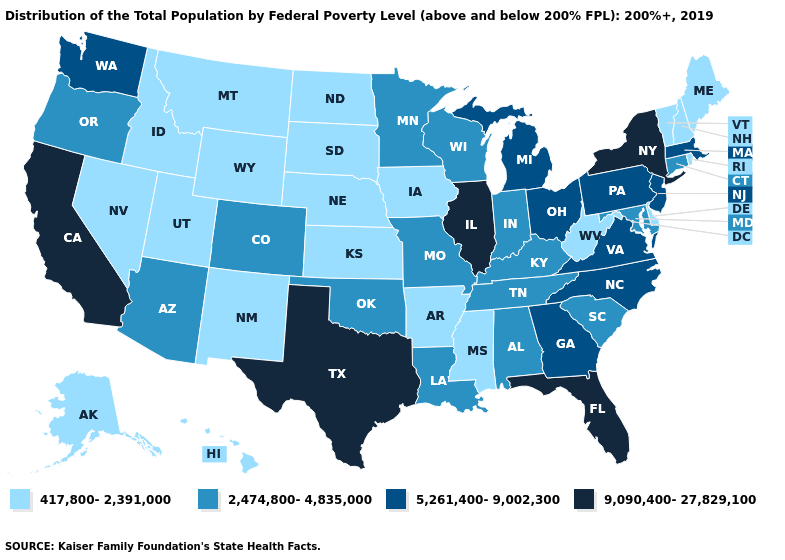Does North Dakota have a lower value than Maryland?
Answer briefly. Yes. Does Wyoming have the same value as Maryland?
Answer briefly. No. How many symbols are there in the legend?
Answer briefly. 4. Does Washington have a higher value than Florida?
Be succinct. No. Name the states that have a value in the range 417,800-2,391,000?
Write a very short answer. Alaska, Arkansas, Delaware, Hawaii, Idaho, Iowa, Kansas, Maine, Mississippi, Montana, Nebraska, Nevada, New Hampshire, New Mexico, North Dakota, Rhode Island, South Dakota, Utah, Vermont, West Virginia, Wyoming. How many symbols are there in the legend?
Short answer required. 4. Does North Carolina have a lower value than Illinois?
Concise answer only. Yes. Among the states that border Virginia , does North Carolina have the highest value?
Give a very brief answer. Yes. What is the highest value in states that border Virginia?
Answer briefly. 5,261,400-9,002,300. Name the states that have a value in the range 5,261,400-9,002,300?
Give a very brief answer. Georgia, Massachusetts, Michigan, New Jersey, North Carolina, Ohio, Pennsylvania, Virginia, Washington. Which states have the highest value in the USA?
Be succinct. California, Florida, Illinois, New York, Texas. Does Texas have the highest value in the South?
Keep it brief. Yes. Does Illinois have the highest value in the MidWest?
Be succinct. Yes. What is the value of Alabama?
Be succinct. 2,474,800-4,835,000. What is the lowest value in states that border New Mexico?
Quick response, please. 417,800-2,391,000. 